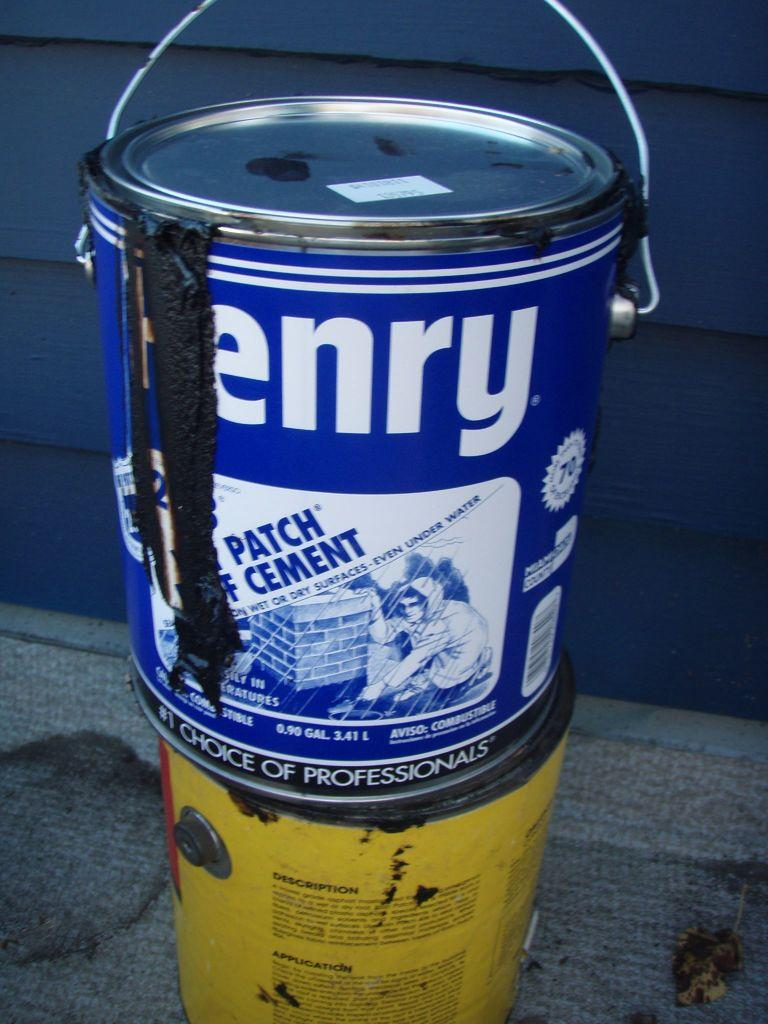<image>
Write a terse but informative summary of the picture. A tin of Henry cement that still has its contents dribbling down its side rests on another tin. 